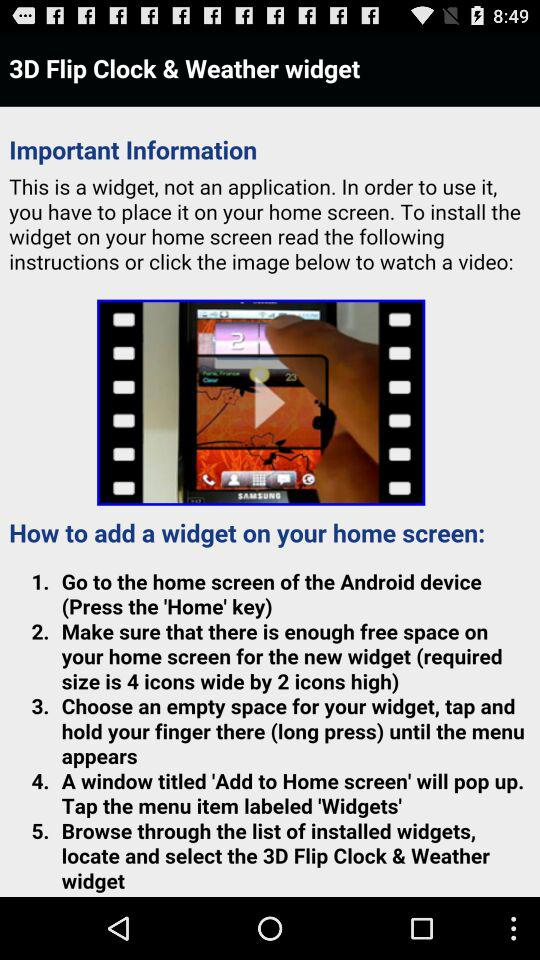How many steps are there in the instructions?
Answer the question using a single word or phrase. 5 